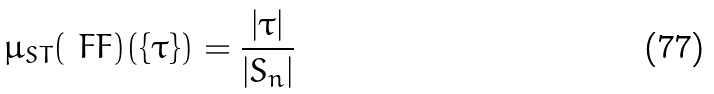<formula> <loc_0><loc_0><loc_500><loc_500>\mu _ { S T } ( \ F F ) ( \{ \tau \} ) = \frac { | \tau | } { | S _ { n } | }</formula> 